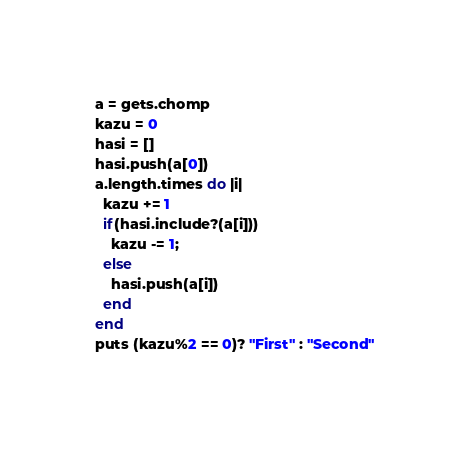<code> <loc_0><loc_0><loc_500><loc_500><_Ruby_>a = gets.chomp
kazu = 0
hasi = []
hasi.push(a[0])
a.length.times do |i|
  kazu += 1
  if(hasi.include?(a[i])) 
    kazu -= 1;
  else
    hasi.push(a[i])
  end
end
puts (kazu%2 == 0)? "First" : "Second"</code> 